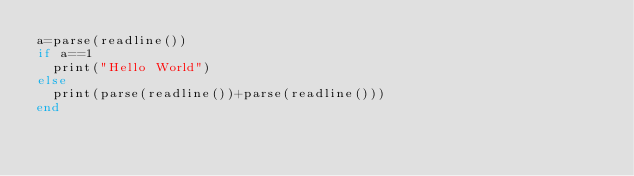<code> <loc_0><loc_0><loc_500><loc_500><_Julia_>a=parse(readline())
if a==1
  print("Hello World")
else
  print(parse(readline())+parse(readline()))
end</code> 